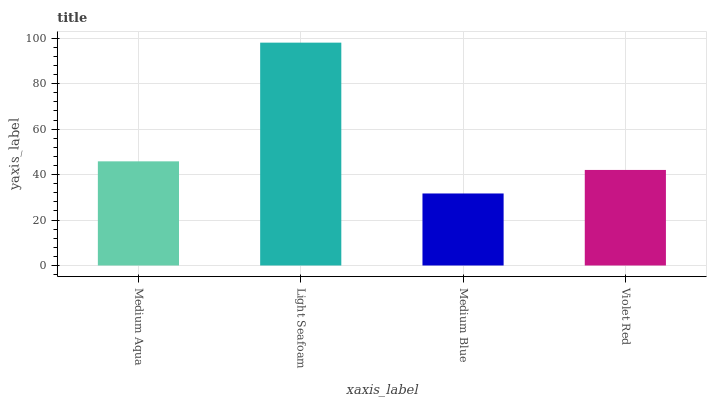Is Medium Blue the minimum?
Answer yes or no. Yes. Is Light Seafoam the maximum?
Answer yes or no. Yes. Is Light Seafoam the minimum?
Answer yes or no. No. Is Medium Blue the maximum?
Answer yes or no. No. Is Light Seafoam greater than Medium Blue?
Answer yes or no. Yes. Is Medium Blue less than Light Seafoam?
Answer yes or no. Yes. Is Medium Blue greater than Light Seafoam?
Answer yes or no. No. Is Light Seafoam less than Medium Blue?
Answer yes or no. No. Is Medium Aqua the high median?
Answer yes or no. Yes. Is Violet Red the low median?
Answer yes or no. Yes. Is Light Seafoam the high median?
Answer yes or no. No. Is Medium Blue the low median?
Answer yes or no. No. 